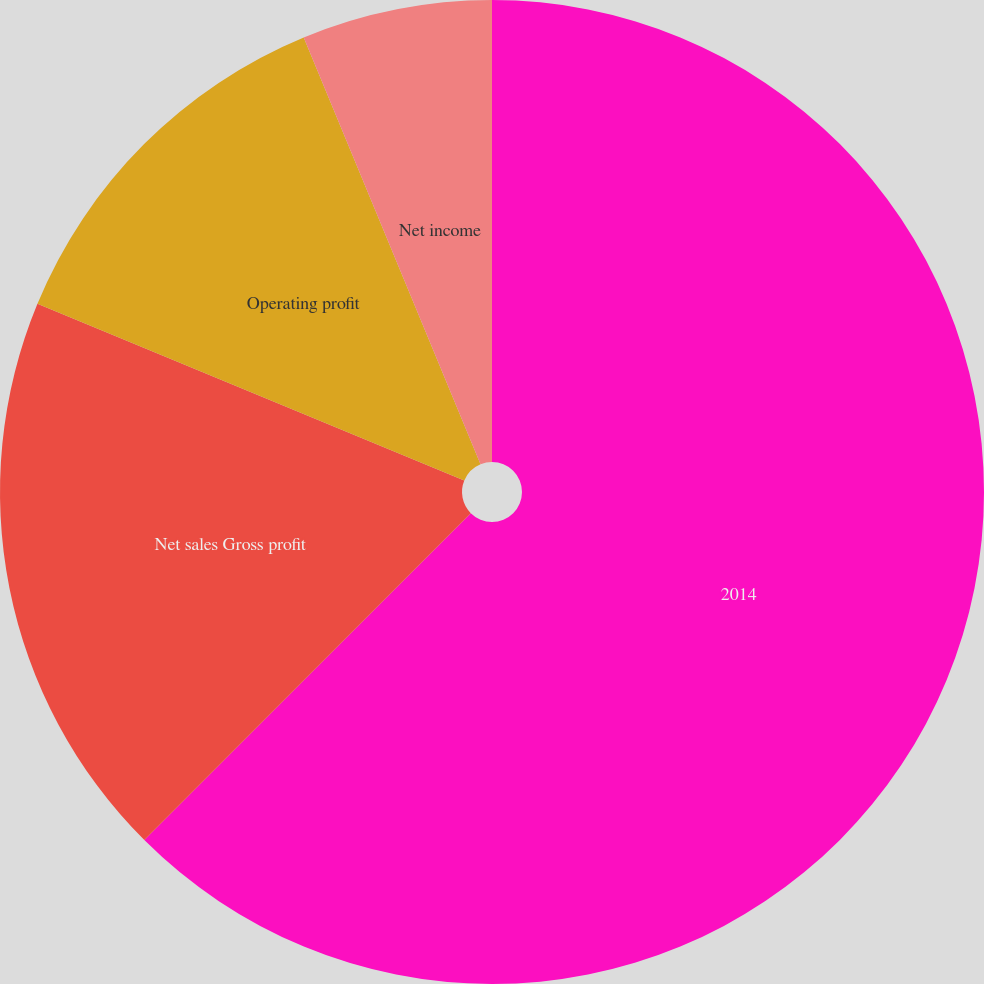<chart> <loc_0><loc_0><loc_500><loc_500><pie_chart><fcel>2014<fcel>Net sales Gross profit<fcel>Operating profit<fcel>Net income<fcel>Basic earnings per share<nl><fcel>62.49%<fcel>18.76%<fcel>12.5%<fcel>6.25%<fcel>0.0%<nl></chart> 